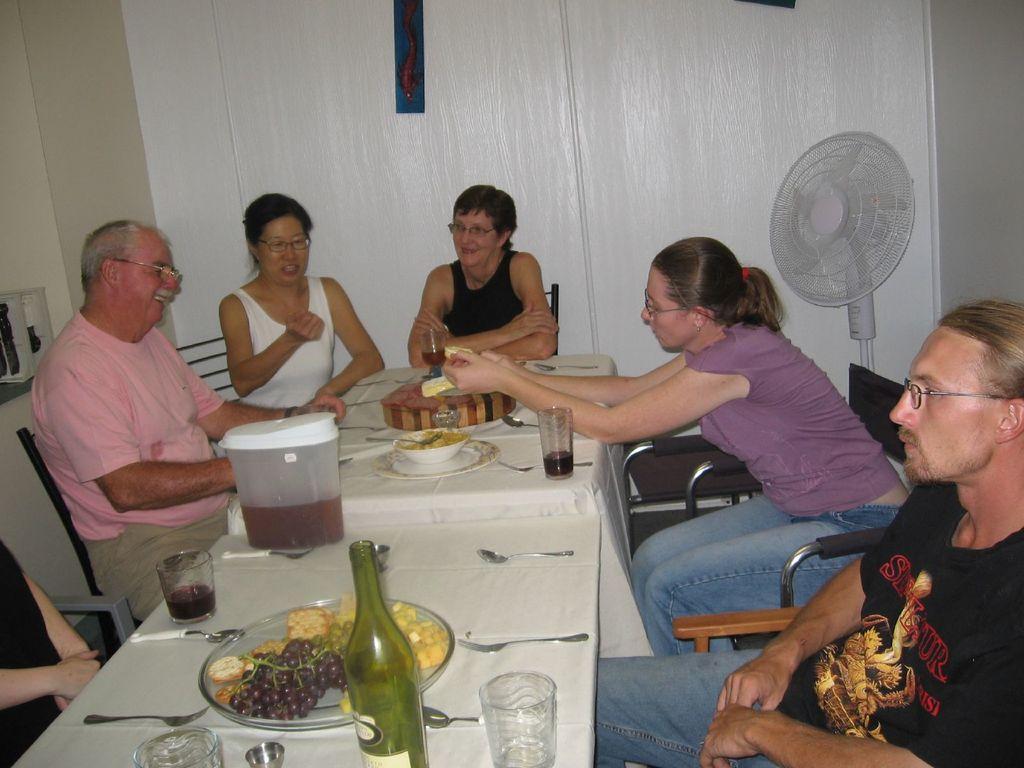Describe this image in one or two sentences. In this picture there are people those who are sitting around the dining table, there are glasses, spoons, and food items on it, there is a fan in the background area of the image. 